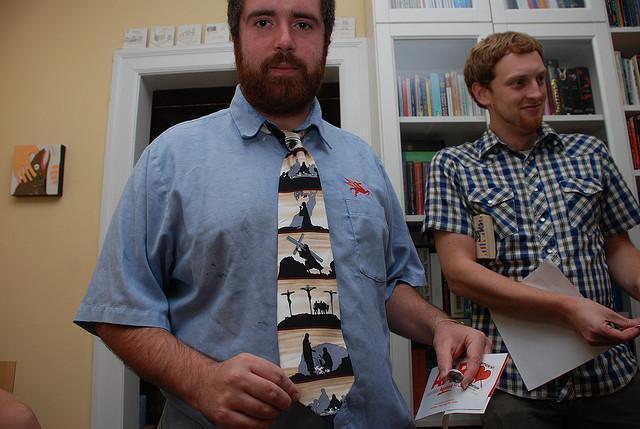How many people can be seen?
Give a very brief answer. 2. 